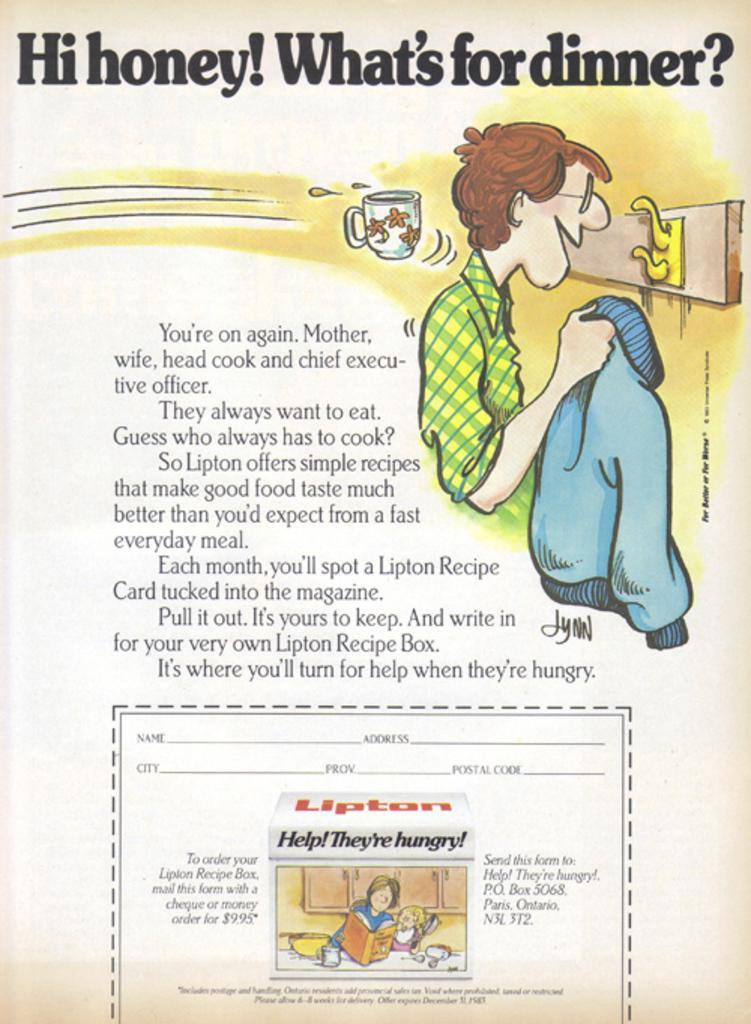Please provide a concise description of this image. It is the picture of some page and there is an animated image of a person and some objects, there is a quotation written beside the animated image. 